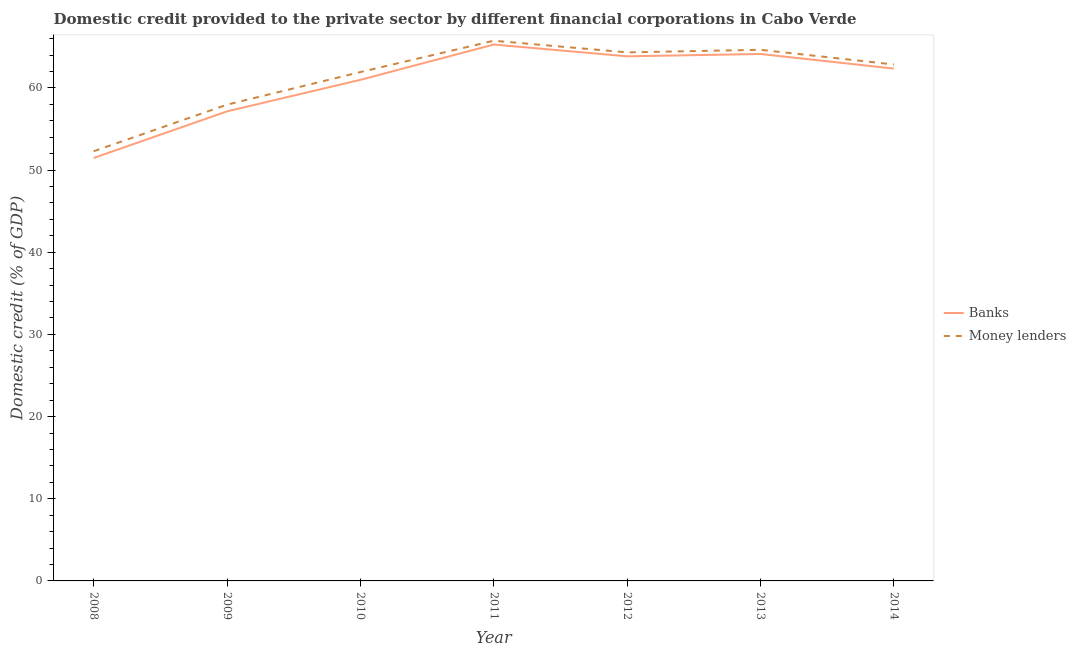Does the line corresponding to domestic credit provided by money lenders intersect with the line corresponding to domestic credit provided by banks?
Offer a very short reply. No. Is the number of lines equal to the number of legend labels?
Your response must be concise. Yes. What is the domestic credit provided by money lenders in 2010?
Provide a short and direct response. 61.93. Across all years, what is the maximum domestic credit provided by banks?
Provide a succinct answer. 65.28. Across all years, what is the minimum domestic credit provided by banks?
Your answer should be very brief. 51.48. What is the total domestic credit provided by banks in the graph?
Give a very brief answer. 425.21. What is the difference between the domestic credit provided by banks in 2010 and that in 2011?
Make the answer very short. -4.29. What is the difference between the domestic credit provided by money lenders in 2011 and the domestic credit provided by banks in 2010?
Offer a terse response. 4.76. What is the average domestic credit provided by money lenders per year?
Your answer should be very brief. 61.39. In the year 2008, what is the difference between the domestic credit provided by money lenders and domestic credit provided by banks?
Ensure brevity in your answer.  0.82. In how many years, is the domestic credit provided by banks greater than 40 %?
Ensure brevity in your answer.  7. What is the ratio of the domestic credit provided by banks in 2009 to that in 2013?
Give a very brief answer. 0.89. What is the difference between the highest and the second highest domestic credit provided by banks?
Your answer should be very brief. 1.15. What is the difference between the highest and the lowest domestic credit provided by money lenders?
Make the answer very short. 13.45. Is the sum of the domestic credit provided by money lenders in 2010 and 2012 greater than the maximum domestic credit provided by banks across all years?
Your answer should be compact. Yes. Does the domestic credit provided by banks monotonically increase over the years?
Your answer should be very brief. No. Is the domestic credit provided by money lenders strictly less than the domestic credit provided by banks over the years?
Offer a very short reply. No. How many years are there in the graph?
Your answer should be compact. 7. What is the difference between two consecutive major ticks on the Y-axis?
Provide a short and direct response. 10. Are the values on the major ticks of Y-axis written in scientific E-notation?
Your response must be concise. No. Does the graph contain grids?
Your response must be concise. No. How many legend labels are there?
Provide a succinct answer. 2. What is the title of the graph?
Offer a very short reply. Domestic credit provided to the private sector by different financial corporations in Cabo Verde. What is the label or title of the X-axis?
Provide a succinct answer. Year. What is the label or title of the Y-axis?
Give a very brief answer. Domestic credit (% of GDP). What is the Domestic credit (% of GDP) in Banks in 2008?
Offer a terse response. 51.48. What is the Domestic credit (% of GDP) of Money lenders in 2008?
Make the answer very short. 52.3. What is the Domestic credit (% of GDP) of Banks in 2009?
Make the answer very short. 57.15. What is the Domestic credit (% of GDP) in Money lenders in 2009?
Ensure brevity in your answer.  57.96. What is the Domestic credit (% of GDP) in Banks in 2010?
Give a very brief answer. 60.99. What is the Domestic credit (% of GDP) in Money lenders in 2010?
Your answer should be compact. 61.93. What is the Domestic credit (% of GDP) in Banks in 2011?
Ensure brevity in your answer.  65.28. What is the Domestic credit (% of GDP) of Money lenders in 2011?
Provide a succinct answer. 65.74. What is the Domestic credit (% of GDP) of Banks in 2012?
Provide a short and direct response. 63.85. What is the Domestic credit (% of GDP) in Money lenders in 2012?
Provide a short and direct response. 64.32. What is the Domestic credit (% of GDP) in Banks in 2013?
Provide a short and direct response. 64.13. What is the Domestic credit (% of GDP) in Money lenders in 2013?
Provide a short and direct response. 64.64. What is the Domestic credit (% of GDP) of Banks in 2014?
Your response must be concise. 62.35. What is the Domestic credit (% of GDP) in Money lenders in 2014?
Provide a short and direct response. 62.85. Across all years, what is the maximum Domestic credit (% of GDP) in Banks?
Provide a succinct answer. 65.28. Across all years, what is the maximum Domestic credit (% of GDP) of Money lenders?
Offer a terse response. 65.74. Across all years, what is the minimum Domestic credit (% of GDP) of Banks?
Keep it short and to the point. 51.48. Across all years, what is the minimum Domestic credit (% of GDP) in Money lenders?
Offer a very short reply. 52.3. What is the total Domestic credit (% of GDP) in Banks in the graph?
Give a very brief answer. 425.21. What is the total Domestic credit (% of GDP) in Money lenders in the graph?
Keep it short and to the point. 429.75. What is the difference between the Domestic credit (% of GDP) in Banks in 2008 and that in 2009?
Your response must be concise. -5.67. What is the difference between the Domestic credit (% of GDP) in Money lenders in 2008 and that in 2009?
Provide a succinct answer. -5.67. What is the difference between the Domestic credit (% of GDP) in Banks in 2008 and that in 2010?
Provide a succinct answer. -9.51. What is the difference between the Domestic credit (% of GDP) in Money lenders in 2008 and that in 2010?
Provide a short and direct response. -9.63. What is the difference between the Domestic credit (% of GDP) in Banks in 2008 and that in 2011?
Offer a terse response. -13.8. What is the difference between the Domestic credit (% of GDP) in Money lenders in 2008 and that in 2011?
Provide a short and direct response. -13.45. What is the difference between the Domestic credit (% of GDP) of Banks in 2008 and that in 2012?
Ensure brevity in your answer.  -12.37. What is the difference between the Domestic credit (% of GDP) in Money lenders in 2008 and that in 2012?
Give a very brief answer. -12.03. What is the difference between the Domestic credit (% of GDP) in Banks in 2008 and that in 2013?
Provide a succinct answer. -12.65. What is the difference between the Domestic credit (% of GDP) of Money lenders in 2008 and that in 2013?
Your answer should be compact. -12.34. What is the difference between the Domestic credit (% of GDP) in Banks in 2008 and that in 2014?
Your response must be concise. -10.88. What is the difference between the Domestic credit (% of GDP) in Money lenders in 2008 and that in 2014?
Your answer should be very brief. -10.55. What is the difference between the Domestic credit (% of GDP) in Banks in 2009 and that in 2010?
Provide a succinct answer. -3.84. What is the difference between the Domestic credit (% of GDP) in Money lenders in 2009 and that in 2010?
Make the answer very short. -3.97. What is the difference between the Domestic credit (% of GDP) in Banks in 2009 and that in 2011?
Your response must be concise. -8.13. What is the difference between the Domestic credit (% of GDP) in Money lenders in 2009 and that in 2011?
Provide a succinct answer. -7.78. What is the difference between the Domestic credit (% of GDP) in Banks in 2009 and that in 2012?
Offer a very short reply. -6.7. What is the difference between the Domestic credit (% of GDP) of Money lenders in 2009 and that in 2012?
Keep it short and to the point. -6.36. What is the difference between the Domestic credit (% of GDP) in Banks in 2009 and that in 2013?
Your answer should be compact. -6.98. What is the difference between the Domestic credit (% of GDP) in Money lenders in 2009 and that in 2013?
Keep it short and to the point. -6.68. What is the difference between the Domestic credit (% of GDP) in Banks in 2009 and that in 2014?
Provide a short and direct response. -5.2. What is the difference between the Domestic credit (% of GDP) in Money lenders in 2009 and that in 2014?
Provide a short and direct response. -4.89. What is the difference between the Domestic credit (% of GDP) in Banks in 2010 and that in 2011?
Give a very brief answer. -4.29. What is the difference between the Domestic credit (% of GDP) of Money lenders in 2010 and that in 2011?
Make the answer very short. -3.81. What is the difference between the Domestic credit (% of GDP) of Banks in 2010 and that in 2012?
Offer a terse response. -2.86. What is the difference between the Domestic credit (% of GDP) in Money lenders in 2010 and that in 2012?
Keep it short and to the point. -2.4. What is the difference between the Domestic credit (% of GDP) of Banks in 2010 and that in 2013?
Provide a succinct answer. -3.14. What is the difference between the Domestic credit (% of GDP) in Money lenders in 2010 and that in 2013?
Your answer should be compact. -2.71. What is the difference between the Domestic credit (% of GDP) in Banks in 2010 and that in 2014?
Make the answer very short. -1.37. What is the difference between the Domestic credit (% of GDP) of Money lenders in 2010 and that in 2014?
Keep it short and to the point. -0.92. What is the difference between the Domestic credit (% of GDP) in Banks in 2011 and that in 2012?
Provide a short and direct response. 1.43. What is the difference between the Domestic credit (% of GDP) in Money lenders in 2011 and that in 2012?
Your answer should be very brief. 1.42. What is the difference between the Domestic credit (% of GDP) in Banks in 2011 and that in 2013?
Make the answer very short. 1.15. What is the difference between the Domestic credit (% of GDP) in Money lenders in 2011 and that in 2013?
Provide a short and direct response. 1.1. What is the difference between the Domestic credit (% of GDP) of Banks in 2011 and that in 2014?
Your answer should be compact. 2.93. What is the difference between the Domestic credit (% of GDP) in Money lenders in 2011 and that in 2014?
Make the answer very short. 2.89. What is the difference between the Domestic credit (% of GDP) in Banks in 2012 and that in 2013?
Offer a very short reply. -0.28. What is the difference between the Domestic credit (% of GDP) of Money lenders in 2012 and that in 2013?
Ensure brevity in your answer.  -0.32. What is the difference between the Domestic credit (% of GDP) of Banks in 2012 and that in 2014?
Your answer should be very brief. 1.49. What is the difference between the Domestic credit (% of GDP) in Money lenders in 2012 and that in 2014?
Keep it short and to the point. 1.47. What is the difference between the Domestic credit (% of GDP) of Banks in 2013 and that in 2014?
Make the answer very short. 1.78. What is the difference between the Domestic credit (% of GDP) of Money lenders in 2013 and that in 2014?
Give a very brief answer. 1.79. What is the difference between the Domestic credit (% of GDP) of Banks in 2008 and the Domestic credit (% of GDP) of Money lenders in 2009?
Your answer should be compact. -6.49. What is the difference between the Domestic credit (% of GDP) of Banks in 2008 and the Domestic credit (% of GDP) of Money lenders in 2010?
Your response must be concise. -10.45. What is the difference between the Domestic credit (% of GDP) in Banks in 2008 and the Domestic credit (% of GDP) in Money lenders in 2011?
Give a very brief answer. -14.27. What is the difference between the Domestic credit (% of GDP) in Banks in 2008 and the Domestic credit (% of GDP) in Money lenders in 2012?
Offer a very short reply. -12.85. What is the difference between the Domestic credit (% of GDP) of Banks in 2008 and the Domestic credit (% of GDP) of Money lenders in 2013?
Your response must be concise. -13.17. What is the difference between the Domestic credit (% of GDP) of Banks in 2008 and the Domestic credit (% of GDP) of Money lenders in 2014?
Your answer should be very brief. -11.38. What is the difference between the Domestic credit (% of GDP) in Banks in 2009 and the Domestic credit (% of GDP) in Money lenders in 2010?
Your answer should be compact. -4.78. What is the difference between the Domestic credit (% of GDP) in Banks in 2009 and the Domestic credit (% of GDP) in Money lenders in 2011?
Offer a very short reply. -8.6. What is the difference between the Domestic credit (% of GDP) of Banks in 2009 and the Domestic credit (% of GDP) of Money lenders in 2012?
Your answer should be very brief. -7.18. What is the difference between the Domestic credit (% of GDP) in Banks in 2009 and the Domestic credit (% of GDP) in Money lenders in 2013?
Give a very brief answer. -7.49. What is the difference between the Domestic credit (% of GDP) of Banks in 2009 and the Domestic credit (% of GDP) of Money lenders in 2014?
Keep it short and to the point. -5.7. What is the difference between the Domestic credit (% of GDP) in Banks in 2010 and the Domestic credit (% of GDP) in Money lenders in 2011?
Offer a very short reply. -4.76. What is the difference between the Domestic credit (% of GDP) of Banks in 2010 and the Domestic credit (% of GDP) of Money lenders in 2012?
Make the answer very short. -3.34. What is the difference between the Domestic credit (% of GDP) in Banks in 2010 and the Domestic credit (% of GDP) in Money lenders in 2013?
Provide a short and direct response. -3.66. What is the difference between the Domestic credit (% of GDP) in Banks in 2010 and the Domestic credit (% of GDP) in Money lenders in 2014?
Give a very brief answer. -1.87. What is the difference between the Domestic credit (% of GDP) in Banks in 2011 and the Domestic credit (% of GDP) in Money lenders in 2012?
Provide a short and direct response. 0.95. What is the difference between the Domestic credit (% of GDP) in Banks in 2011 and the Domestic credit (% of GDP) in Money lenders in 2013?
Provide a succinct answer. 0.64. What is the difference between the Domestic credit (% of GDP) in Banks in 2011 and the Domestic credit (% of GDP) in Money lenders in 2014?
Make the answer very short. 2.43. What is the difference between the Domestic credit (% of GDP) of Banks in 2012 and the Domestic credit (% of GDP) of Money lenders in 2013?
Make the answer very short. -0.79. What is the difference between the Domestic credit (% of GDP) in Banks in 2012 and the Domestic credit (% of GDP) in Money lenders in 2014?
Offer a terse response. 0.99. What is the difference between the Domestic credit (% of GDP) in Banks in 2013 and the Domestic credit (% of GDP) in Money lenders in 2014?
Your answer should be very brief. 1.28. What is the average Domestic credit (% of GDP) of Banks per year?
Make the answer very short. 60.74. What is the average Domestic credit (% of GDP) in Money lenders per year?
Provide a succinct answer. 61.39. In the year 2008, what is the difference between the Domestic credit (% of GDP) in Banks and Domestic credit (% of GDP) in Money lenders?
Offer a terse response. -0.82. In the year 2009, what is the difference between the Domestic credit (% of GDP) in Banks and Domestic credit (% of GDP) in Money lenders?
Your answer should be compact. -0.82. In the year 2010, what is the difference between the Domestic credit (% of GDP) in Banks and Domestic credit (% of GDP) in Money lenders?
Provide a short and direct response. -0.94. In the year 2011, what is the difference between the Domestic credit (% of GDP) of Banks and Domestic credit (% of GDP) of Money lenders?
Make the answer very short. -0.46. In the year 2012, what is the difference between the Domestic credit (% of GDP) of Banks and Domestic credit (% of GDP) of Money lenders?
Keep it short and to the point. -0.48. In the year 2013, what is the difference between the Domestic credit (% of GDP) of Banks and Domestic credit (% of GDP) of Money lenders?
Offer a very short reply. -0.51. In the year 2014, what is the difference between the Domestic credit (% of GDP) in Banks and Domestic credit (% of GDP) in Money lenders?
Make the answer very short. -0.5. What is the ratio of the Domestic credit (% of GDP) of Banks in 2008 to that in 2009?
Make the answer very short. 0.9. What is the ratio of the Domestic credit (% of GDP) of Money lenders in 2008 to that in 2009?
Your response must be concise. 0.9. What is the ratio of the Domestic credit (% of GDP) in Banks in 2008 to that in 2010?
Keep it short and to the point. 0.84. What is the ratio of the Domestic credit (% of GDP) in Money lenders in 2008 to that in 2010?
Provide a succinct answer. 0.84. What is the ratio of the Domestic credit (% of GDP) in Banks in 2008 to that in 2011?
Give a very brief answer. 0.79. What is the ratio of the Domestic credit (% of GDP) of Money lenders in 2008 to that in 2011?
Your response must be concise. 0.8. What is the ratio of the Domestic credit (% of GDP) of Banks in 2008 to that in 2012?
Your answer should be very brief. 0.81. What is the ratio of the Domestic credit (% of GDP) of Money lenders in 2008 to that in 2012?
Your answer should be compact. 0.81. What is the ratio of the Domestic credit (% of GDP) of Banks in 2008 to that in 2013?
Ensure brevity in your answer.  0.8. What is the ratio of the Domestic credit (% of GDP) in Money lenders in 2008 to that in 2013?
Provide a succinct answer. 0.81. What is the ratio of the Domestic credit (% of GDP) in Banks in 2008 to that in 2014?
Offer a very short reply. 0.83. What is the ratio of the Domestic credit (% of GDP) in Money lenders in 2008 to that in 2014?
Provide a succinct answer. 0.83. What is the ratio of the Domestic credit (% of GDP) of Banks in 2009 to that in 2010?
Give a very brief answer. 0.94. What is the ratio of the Domestic credit (% of GDP) in Money lenders in 2009 to that in 2010?
Provide a short and direct response. 0.94. What is the ratio of the Domestic credit (% of GDP) in Banks in 2009 to that in 2011?
Your answer should be very brief. 0.88. What is the ratio of the Domestic credit (% of GDP) of Money lenders in 2009 to that in 2011?
Provide a succinct answer. 0.88. What is the ratio of the Domestic credit (% of GDP) in Banks in 2009 to that in 2012?
Provide a succinct answer. 0.9. What is the ratio of the Domestic credit (% of GDP) of Money lenders in 2009 to that in 2012?
Offer a very short reply. 0.9. What is the ratio of the Domestic credit (% of GDP) in Banks in 2009 to that in 2013?
Offer a terse response. 0.89. What is the ratio of the Domestic credit (% of GDP) in Money lenders in 2009 to that in 2013?
Your answer should be very brief. 0.9. What is the ratio of the Domestic credit (% of GDP) in Banks in 2009 to that in 2014?
Your answer should be compact. 0.92. What is the ratio of the Domestic credit (% of GDP) of Money lenders in 2009 to that in 2014?
Keep it short and to the point. 0.92. What is the ratio of the Domestic credit (% of GDP) in Banks in 2010 to that in 2011?
Make the answer very short. 0.93. What is the ratio of the Domestic credit (% of GDP) in Money lenders in 2010 to that in 2011?
Keep it short and to the point. 0.94. What is the ratio of the Domestic credit (% of GDP) of Banks in 2010 to that in 2012?
Make the answer very short. 0.96. What is the ratio of the Domestic credit (% of GDP) in Money lenders in 2010 to that in 2012?
Your response must be concise. 0.96. What is the ratio of the Domestic credit (% of GDP) of Banks in 2010 to that in 2013?
Your answer should be very brief. 0.95. What is the ratio of the Domestic credit (% of GDP) of Money lenders in 2010 to that in 2013?
Offer a terse response. 0.96. What is the ratio of the Domestic credit (% of GDP) in Banks in 2010 to that in 2014?
Your response must be concise. 0.98. What is the ratio of the Domestic credit (% of GDP) in Money lenders in 2010 to that in 2014?
Offer a terse response. 0.99. What is the ratio of the Domestic credit (% of GDP) in Banks in 2011 to that in 2012?
Keep it short and to the point. 1.02. What is the ratio of the Domestic credit (% of GDP) in Money lenders in 2011 to that in 2012?
Offer a very short reply. 1.02. What is the ratio of the Domestic credit (% of GDP) in Banks in 2011 to that in 2013?
Your answer should be compact. 1.02. What is the ratio of the Domestic credit (% of GDP) in Banks in 2011 to that in 2014?
Give a very brief answer. 1.05. What is the ratio of the Domestic credit (% of GDP) of Money lenders in 2011 to that in 2014?
Provide a succinct answer. 1.05. What is the ratio of the Domestic credit (% of GDP) in Money lenders in 2012 to that in 2013?
Your answer should be compact. 1. What is the ratio of the Domestic credit (% of GDP) in Banks in 2012 to that in 2014?
Offer a very short reply. 1.02. What is the ratio of the Domestic credit (% of GDP) of Money lenders in 2012 to that in 2014?
Offer a terse response. 1.02. What is the ratio of the Domestic credit (% of GDP) in Banks in 2013 to that in 2014?
Offer a very short reply. 1.03. What is the ratio of the Domestic credit (% of GDP) in Money lenders in 2013 to that in 2014?
Offer a very short reply. 1.03. What is the difference between the highest and the second highest Domestic credit (% of GDP) in Banks?
Make the answer very short. 1.15. What is the difference between the highest and the second highest Domestic credit (% of GDP) in Money lenders?
Ensure brevity in your answer.  1.1. What is the difference between the highest and the lowest Domestic credit (% of GDP) in Banks?
Your answer should be very brief. 13.8. What is the difference between the highest and the lowest Domestic credit (% of GDP) of Money lenders?
Provide a short and direct response. 13.45. 